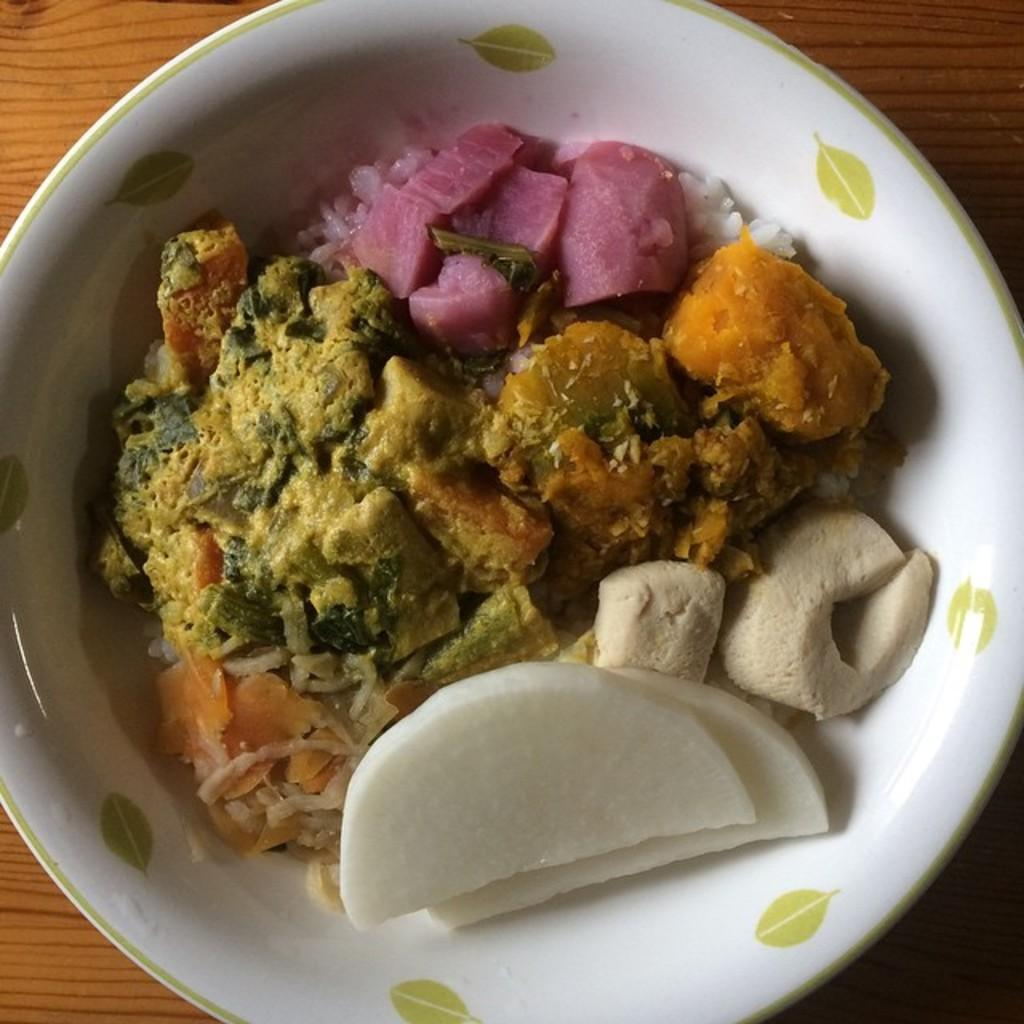What color is the bowl that is visible in the image? There is a white bowl in the image. What is inside the white bowl? There is food in the white bowl. On what surface is the white bowl placed? The white bowl is placed on a brown surface. What type of shoe is visible in the image? There is no shoe present in the image. 